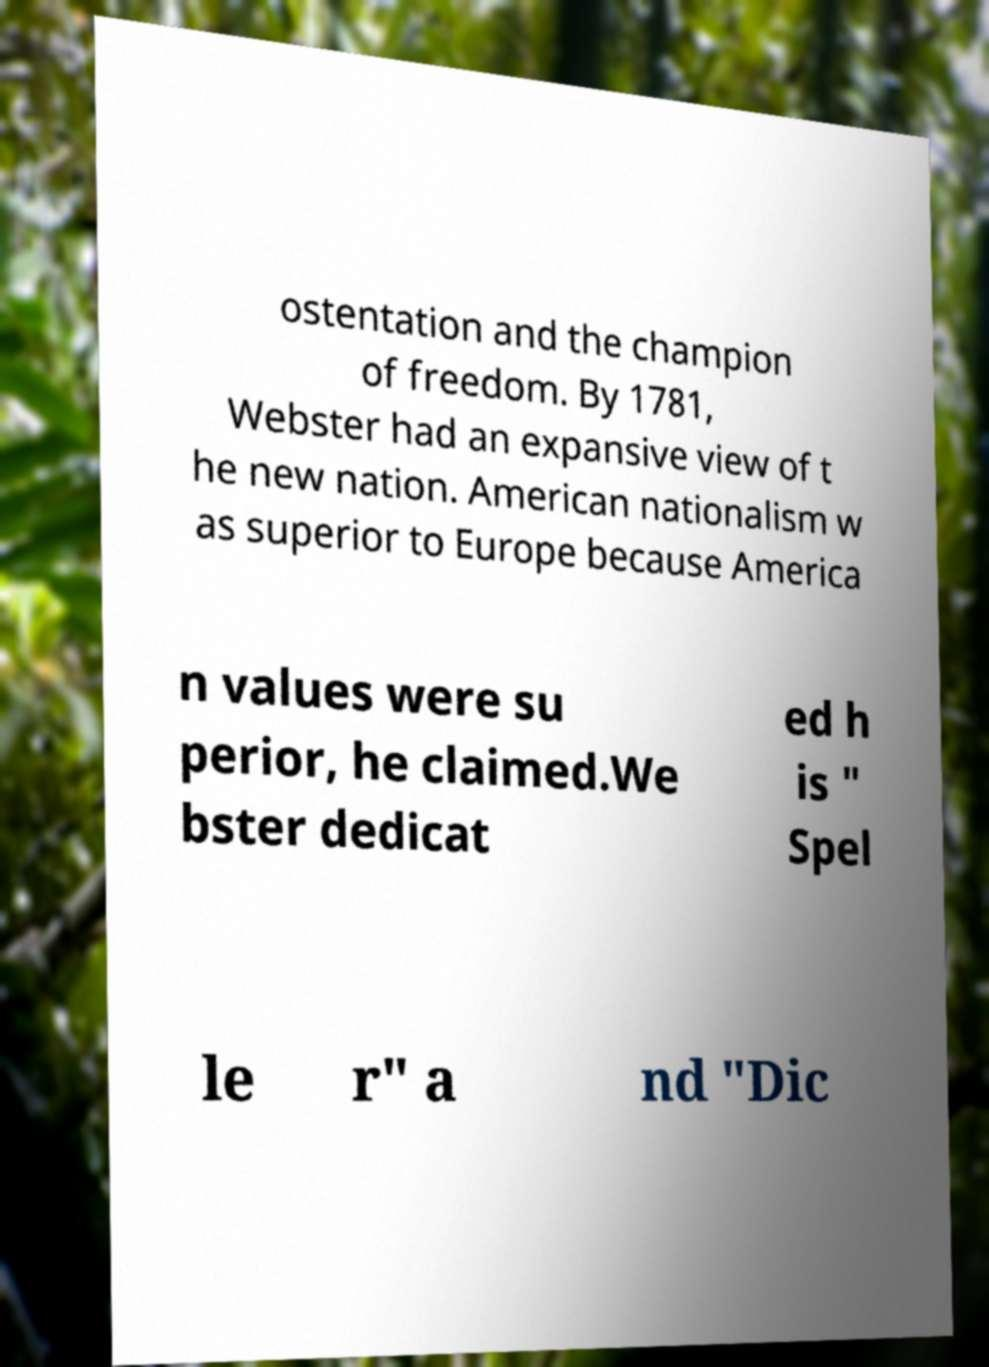Please identify and transcribe the text found in this image. ostentation and the champion of freedom. By 1781, Webster had an expansive view of t he new nation. American nationalism w as superior to Europe because America n values were su perior, he claimed.We bster dedicat ed h is " Spel le r" a nd "Dic 